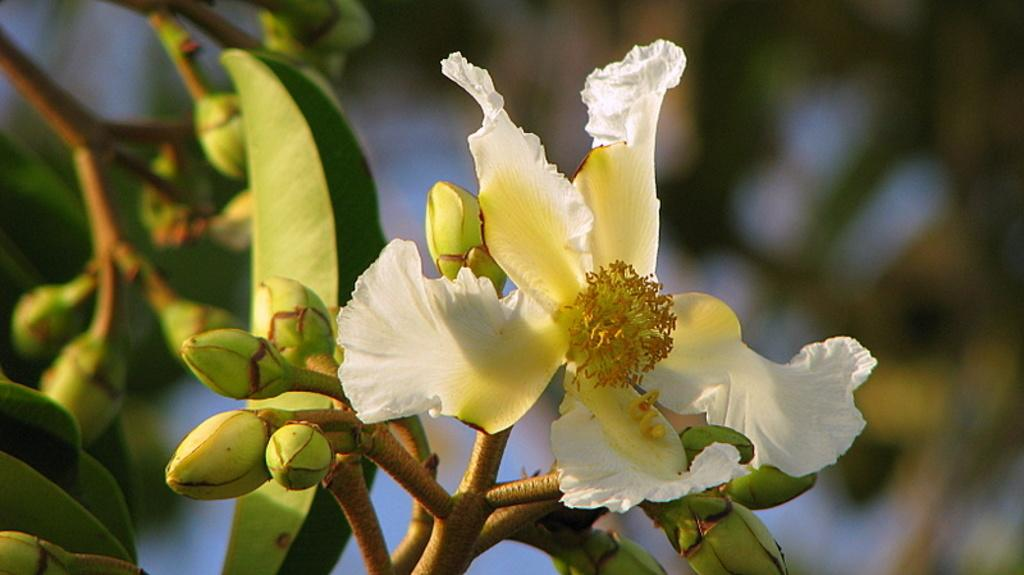What type of plant is visible in the image? There is a flower in the image. What other parts of the plant can be seen in the image? There are leaves and buds in the image. How would you describe the background of the image? The background of the image is blurry. How is the faucet being used in the image? There is no faucet present in the image. What type of fire can be seen in the image? There is no fire present in the image. 